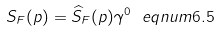Convert formula to latex. <formula><loc_0><loc_0><loc_500><loc_500>S _ { F } ( p ) = \widehat { S } _ { F } ( p ) \gamma ^ { 0 } \ e q n u m { 6 . 5 }</formula> 